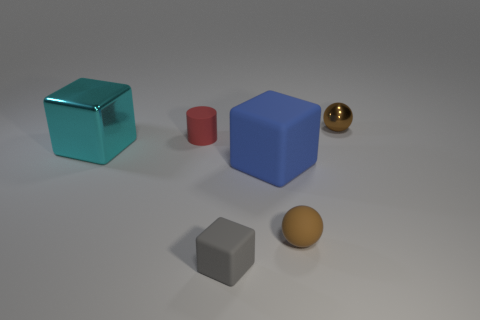Add 4 brown shiny things. How many objects exist? 10 Subtract all balls. How many objects are left? 4 Add 1 tiny purple matte things. How many tiny purple matte things exist? 1 Subtract 0 yellow balls. How many objects are left? 6 Subtract all blue rubber cubes. Subtract all small gray things. How many objects are left? 4 Add 5 small brown matte spheres. How many small brown matte spheres are left? 6 